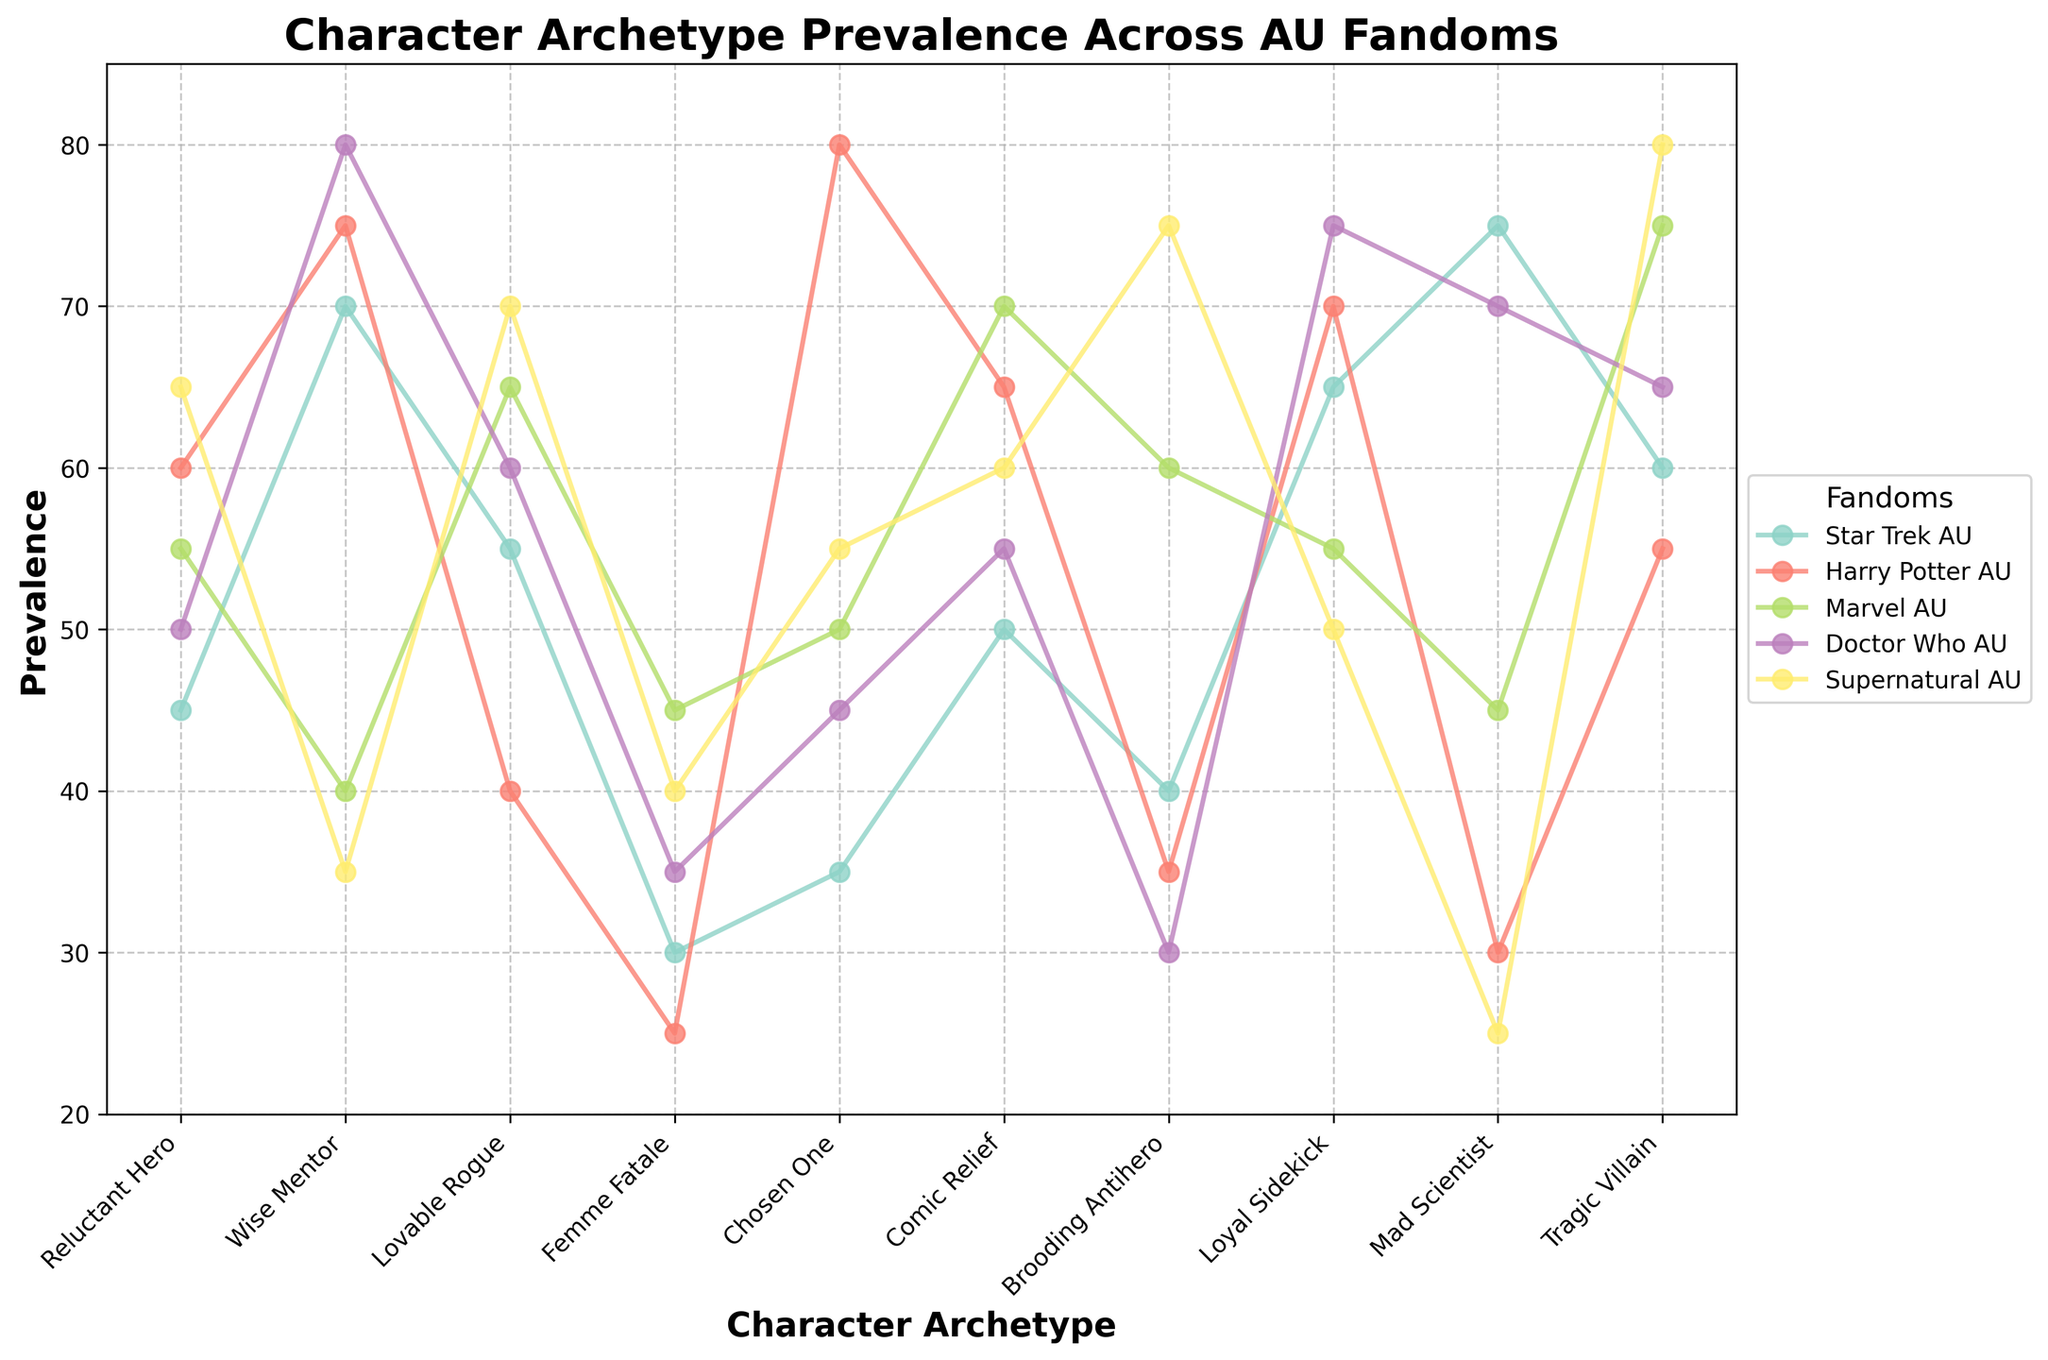Which character archetype has the highest prevalence in the "Doctor Who AU"? The highest point on the "Doctor Who AU" line should be identified as the one with the maximum Y value. For "Doctor Who AU," the character archetype with the highest prevalence is "Wise Mentor" (80).
Answer: Wise Mentor Which two archetypes have the lowest prevalence in "Supernatural AU"? Look for the two lowest points on the "Supernatural AU" line. These points represent "Mad Scientist" (25) and "Wise Mentor" (35).
Answer: Mad Scientist, Wise Mentor Which fandom has the highest prevalence for the "Tragic Villain" archetype? Identify the highest point on the "Tragic Villain" line. "Supernatural AU" has the highest value (80) for this archetype.
Answer: Supernatural AU Which archetype shows significant variance across different fandoms? By visually comparing the rise and fall of values for each archetype across multiple fandoms, the "Mad Scientist" archetype shows high variance with values ranging from 25 to 75.
Answer: Mad Scientist What is the average prevalence of the "Loyal Sidekick" across all fandoms? The prevalence values for the "Loyal Sidekick" archetype across all fandoms are 65, 70, 55, 75, and 50. Sum these values: 65 + 70 + 55 + 75 + 50 = 315. Divide by the number of fandoms (5): 315 / 5 = 63.
Answer: 63 How does the prevalence of the "Femme Fatale" archetype in "Harry Potter AU" compare to "Marvel AU"? The "Femme Fatale" archetype has a prevalence of 25 in "Harry Potter AU" and 45 in "Marvel AU". Comparing these, "Marvel AU" has a higher prevalence.
Answer: Marvel AU What is the second most prevalent archetype in the "Star Trek AU"? Identify the second highest point on the "Star Trek AU" line. It should be the "Tragic Villain" archetype (60).
Answer: Tragic Villain Which character archetype shows a similar pattern between "Doctor Who AU" and "Marvel AU"? By comparing the shapes and peaks of the lines, the "Lovable Rogue" archetype shows a similar pattern with prevalences of 60 and 65, respectively.
Answer: Lovable Rogue 